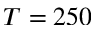Convert formula to latex. <formula><loc_0><loc_0><loc_500><loc_500>T = 2 5 0</formula> 